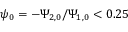<formula> <loc_0><loc_0><loc_500><loc_500>\psi _ { 0 } = - \Psi _ { 2 , 0 } / \Psi _ { 1 , 0 } < 0 . 2 5</formula> 